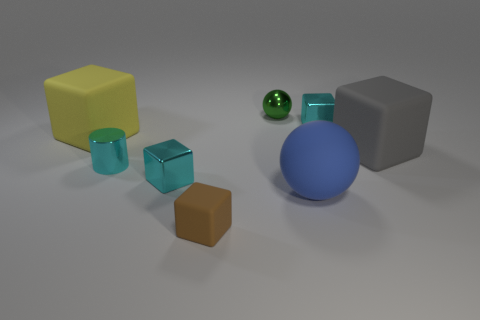Subtract all green cylinders. Subtract all brown spheres. How many cylinders are left? 1 Add 1 small metal cylinders. How many objects exist? 9 Subtract all cubes. How many objects are left? 3 Subtract all blue cubes. Subtract all green objects. How many objects are left? 7 Add 1 tiny brown things. How many tiny brown things are left? 2 Add 3 big green metal cubes. How many big green metal cubes exist? 3 Subtract 1 cyan cylinders. How many objects are left? 7 